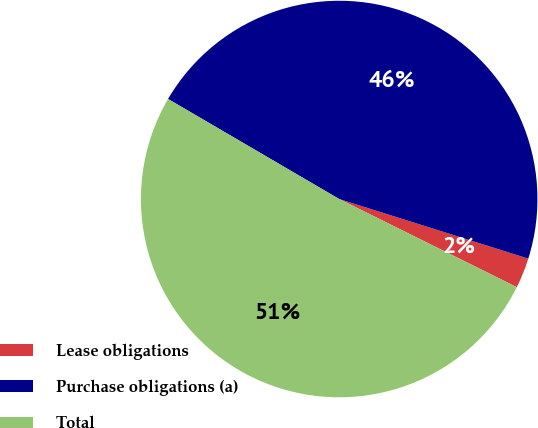Convert chart. <chart><loc_0><loc_0><loc_500><loc_500><pie_chart><fcel>Lease obligations<fcel>Purchase obligations (a)<fcel>Total<nl><fcel>2.47%<fcel>46.44%<fcel>51.09%<nl></chart> 